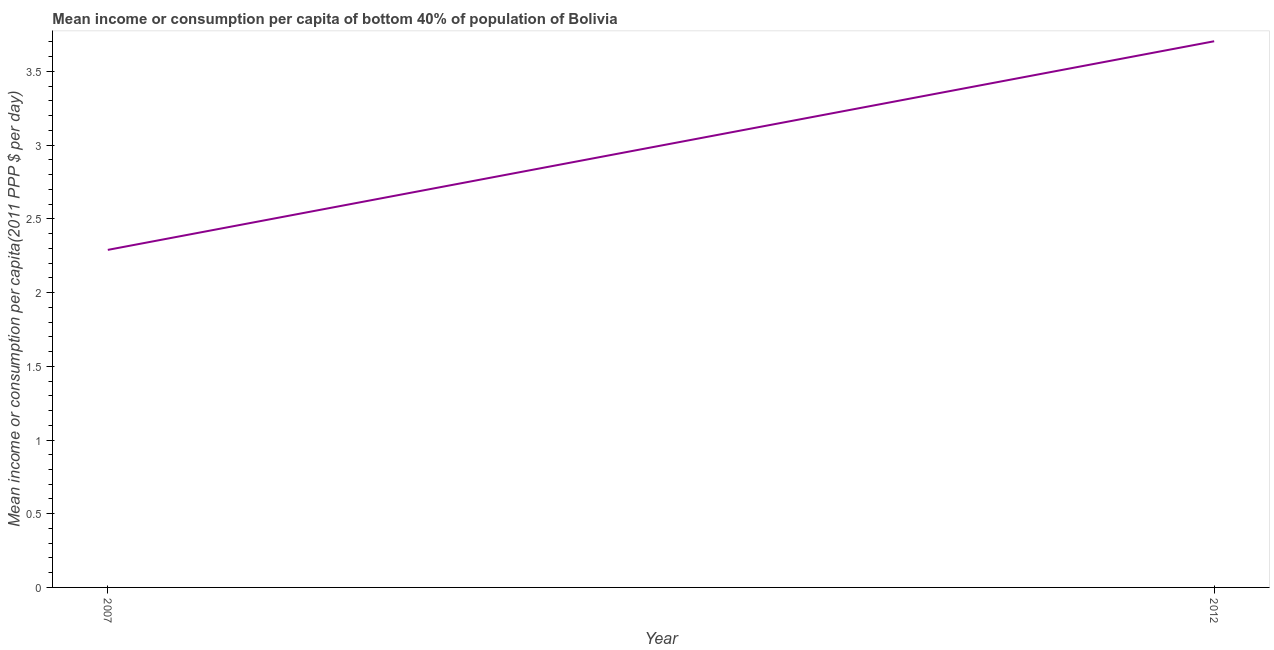What is the mean income or consumption in 2007?
Your answer should be compact. 2.29. Across all years, what is the maximum mean income or consumption?
Your response must be concise. 3.7. Across all years, what is the minimum mean income or consumption?
Your answer should be very brief. 2.29. In which year was the mean income or consumption minimum?
Keep it short and to the point. 2007. What is the sum of the mean income or consumption?
Ensure brevity in your answer.  5.99. What is the difference between the mean income or consumption in 2007 and 2012?
Your answer should be very brief. -1.42. What is the average mean income or consumption per year?
Your answer should be compact. 3. What is the median mean income or consumption?
Make the answer very short. 3. What is the ratio of the mean income or consumption in 2007 to that in 2012?
Provide a succinct answer. 0.62. Is the mean income or consumption in 2007 less than that in 2012?
Give a very brief answer. Yes. In how many years, is the mean income or consumption greater than the average mean income or consumption taken over all years?
Your answer should be very brief. 1. Does the mean income or consumption monotonically increase over the years?
Ensure brevity in your answer.  Yes. How many lines are there?
Keep it short and to the point. 1. How many years are there in the graph?
Your response must be concise. 2. Does the graph contain grids?
Provide a short and direct response. No. What is the title of the graph?
Provide a succinct answer. Mean income or consumption per capita of bottom 40% of population of Bolivia. What is the label or title of the Y-axis?
Your answer should be very brief. Mean income or consumption per capita(2011 PPP $ per day). What is the Mean income or consumption per capita(2011 PPP $ per day) in 2007?
Make the answer very short. 2.29. What is the Mean income or consumption per capita(2011 PPP $ per day) in 2012?
Offer a very short reply. 3.7. What is the difference between the Mean income or consumption per capita(2011 PPP $ per day) in 2007 and 2012?
Give a very brief answer. -1.42. What is the ratio of the Mean income or consumption per capita(2011 PPP $ per day) in 2007 to that in 2012?
Provide a succinct answer. 0.62. 